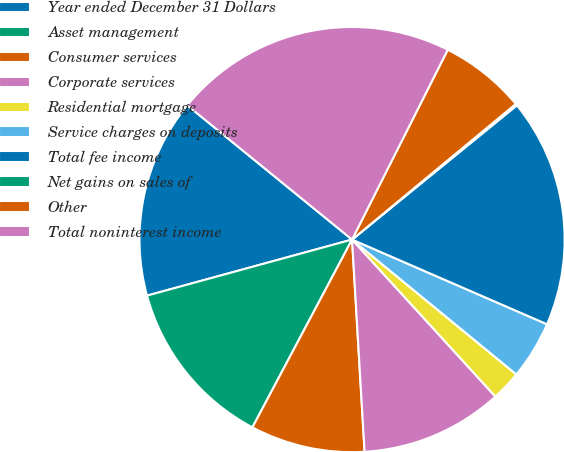Convert chart. <chart><loc_0><loc_0><loc_500><loc_500><pie_chart><fcel>Year ended December 31 Dollars<fcel>Asset management<fcel>Consumer services<fcel>Corporate services<fcel>Residential mortgage<fcel>Service charges on deposits<fcel>Total fee income<fcel>Net gains on sales of<fcel>Other<fcel>Total noninterest income<nl><fcel>15.13%<fcel>12.99%<fcel>8.7%<fcel>10.84%<fcel>2.28%<fcel>4.42%<fcel>17.4%<fcel>0.13%<fcel>6.56%<fcel>21.55%<nl></chart> 